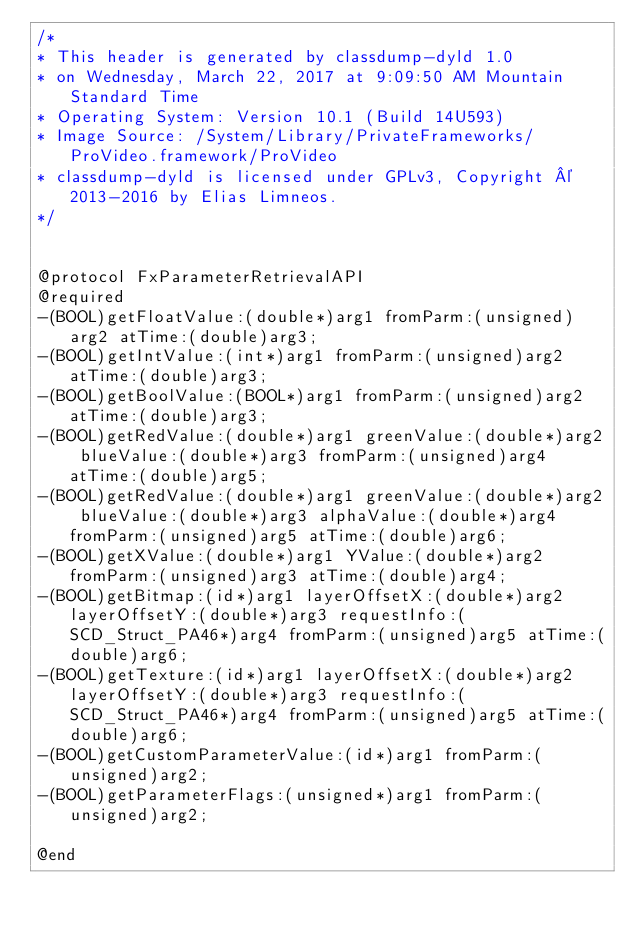<code> <loc_0><loc_0><loc_500><loc_500><_C_>/*
* This header is generated by classdump-dyld 1.0
* on Wednesday, March 22, 2017 at 9:09:50 AM Mountain Standard Time
* Operating System: Version 10.1 (Build 14U593)
* Image Source: /System/Library/PrivateFrameworks/ProVideo.framework/ProVideo
* classdump-dyld is licensed under GPLv3, Copyright © 2013-2016 by Elias Limneos.
*/


@protocol FxParameterRetrievalAPI
@required
-(BOOL)getFloatValue:(double*)arg1 fromParm:(unsigned)arg2 atTime:(double)arg3;
-(BOOL)getIntValue:(int*)arg1 fromParm:(unsigned)arg2 atTime:(double)arg3;
-(BOOL)getBoolValue:(BOOL*)arg1 fromParm:(unsigned)arg2 atTime:(double)arg3;
-(BOOL)getRedValue:(double*)arg1 greenValue:(double*)arg2 blueValue:(double*)arg3 fromParm:(unsigned)arg4 atTime:(double)arg5;
-(BOOL)getRedValue:(double*)arg1 greenValue:(double*)arg2 blueValue:(double*)arg3 alphaValue:(double*)arg4 fromParm:(unsigned)arg5 atTime:(double)arg6;
-(BOOL)getXValue:(double*)arg1 YValue:(double*)arg2 fromParm:(unsigned)arg3 atTime:(double)arg4;
-(BOOL)getBitmap:(id*)arg1 layerOffsetX:(double*)arg2 layerOffsetY:(double*)arg3 requestInfo:(SCD_Struct_PA46*)arg4 fromParm:(unsigned)arg5 atTime:(double)arg6;
-(BOOL)getTexture:(id*)arg1 layerOffsetX:(double*)arg2 layerOffsetY:(double*)arg3 requestInfo:(SCD_Struct_PA46*)arg4 fromParm:(unsigned)arg5 atTime:(double)arg6;
-(BOOL)getCustomParameterValue:(id*)arg1 fromParm:(unsigned)arg2;
-(BOOL)getParameterFlags:(unsigned*)arg1 fromParm:(unsigned)arg2;

@end

</code> 